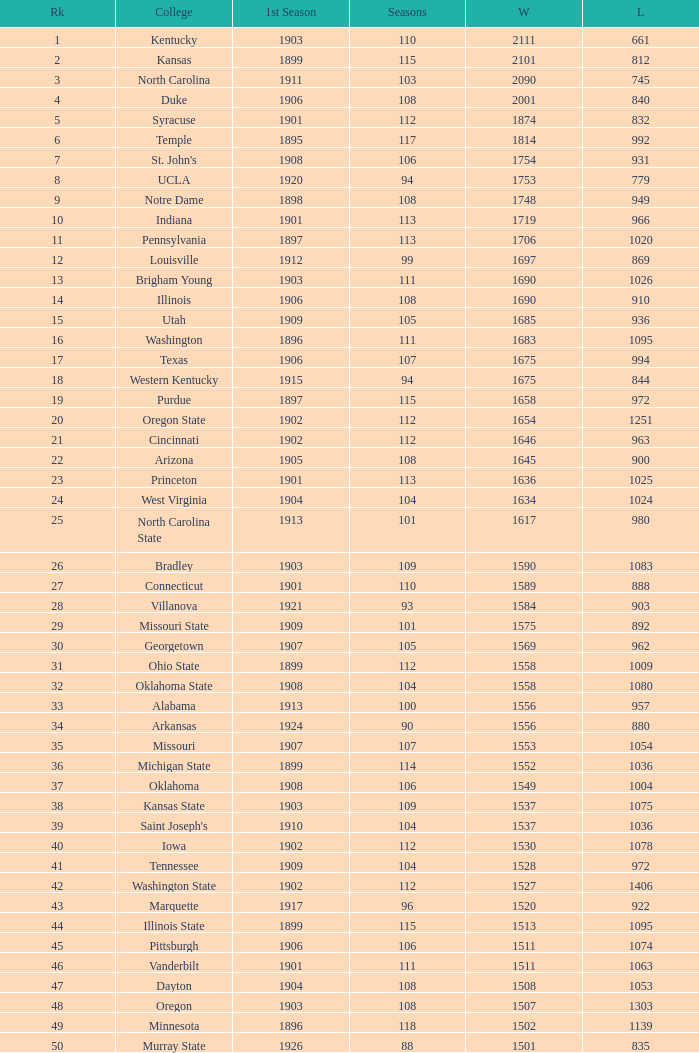What is the total number of rank with losses less than 992, North Carolina State College and a season greater than 101? 0.0. 